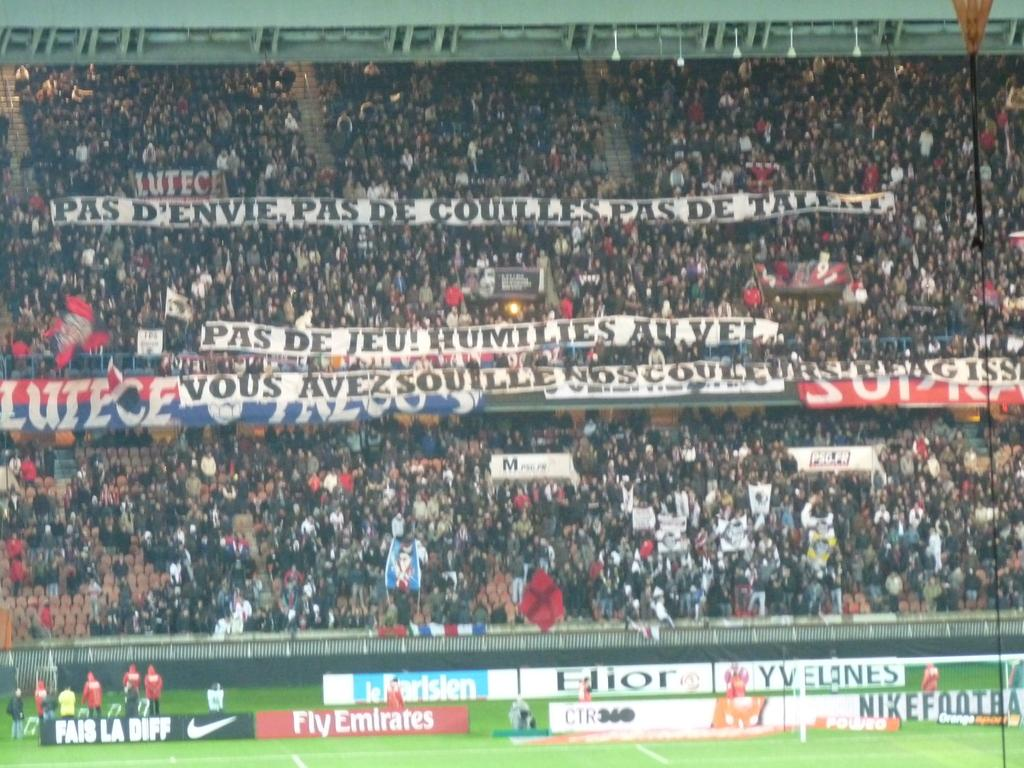<image>
Relay a brief, clear account of the picture shown. the word humilies is on the sign in the crowd 